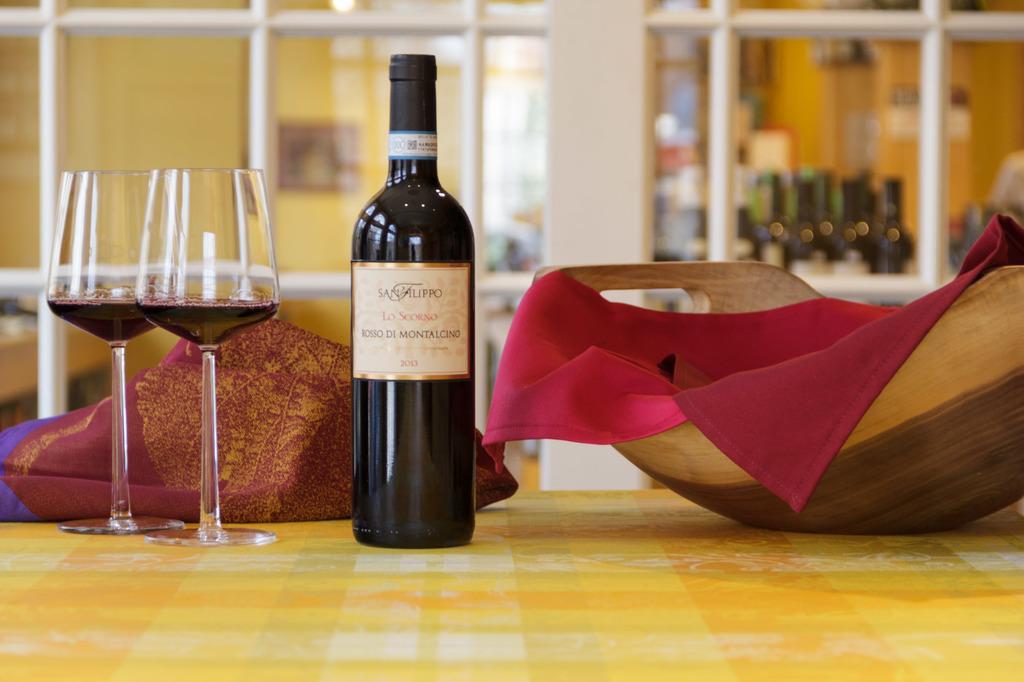What year is printed on the wine label?
Offer a terse response. 2013. 